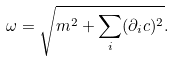Convert formula to latex. <formula><loc_0><loc_0><loc_500><loc_500>\omega = \sqrt { m ^ { 2 } + \sum _ { i } ( \partial _ { i } c ) ^ { 2 } } .</formula> 